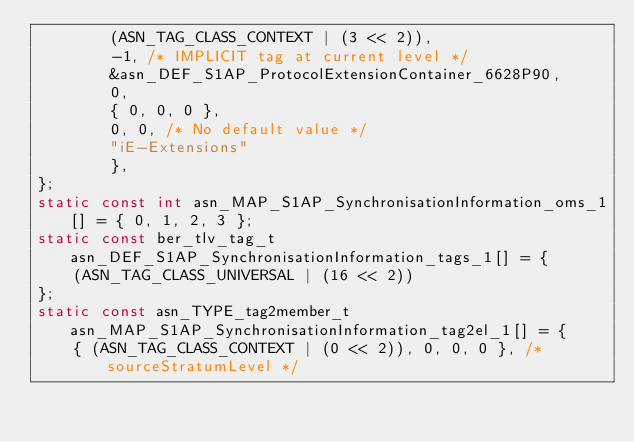Convert code to text. <code><loc_0><loc_0><loc_500><loc_500><_C_>		(ASN_TAG_CLASS_CONTEXT | (3 << 2)),
		-1,	/* IMPLICIT tag at current level */
		&asn_DEF_S1AP_ProtocolExtensionContainer_6628P90,
		0,
		{ 0, 0, 0 },
		0, 0, /* No default value */
		"iE-Extensions"
		},
};
static const int asn_MAP_S1AP_SynchronisationInformation_oms_1[] = { 0, 1, 2, 3 };
static const ber_tlv_tag_t asn_DEF_S1AP_SynchronisationInformation_tags_1[] = {
	(ASN_TAG_CLASS_UNIVERSAL | (16 << 2))
};
static const asn_TYPE_tag2member_t asn_MAP_S1AP_SynchronisationInformation_tag2el_1[] = {
    { (ASN_TAG_CLASS_CONTEXT | (0 << 2)), 0, 0, 0 }, /* sourceStratumLevel */</code> 